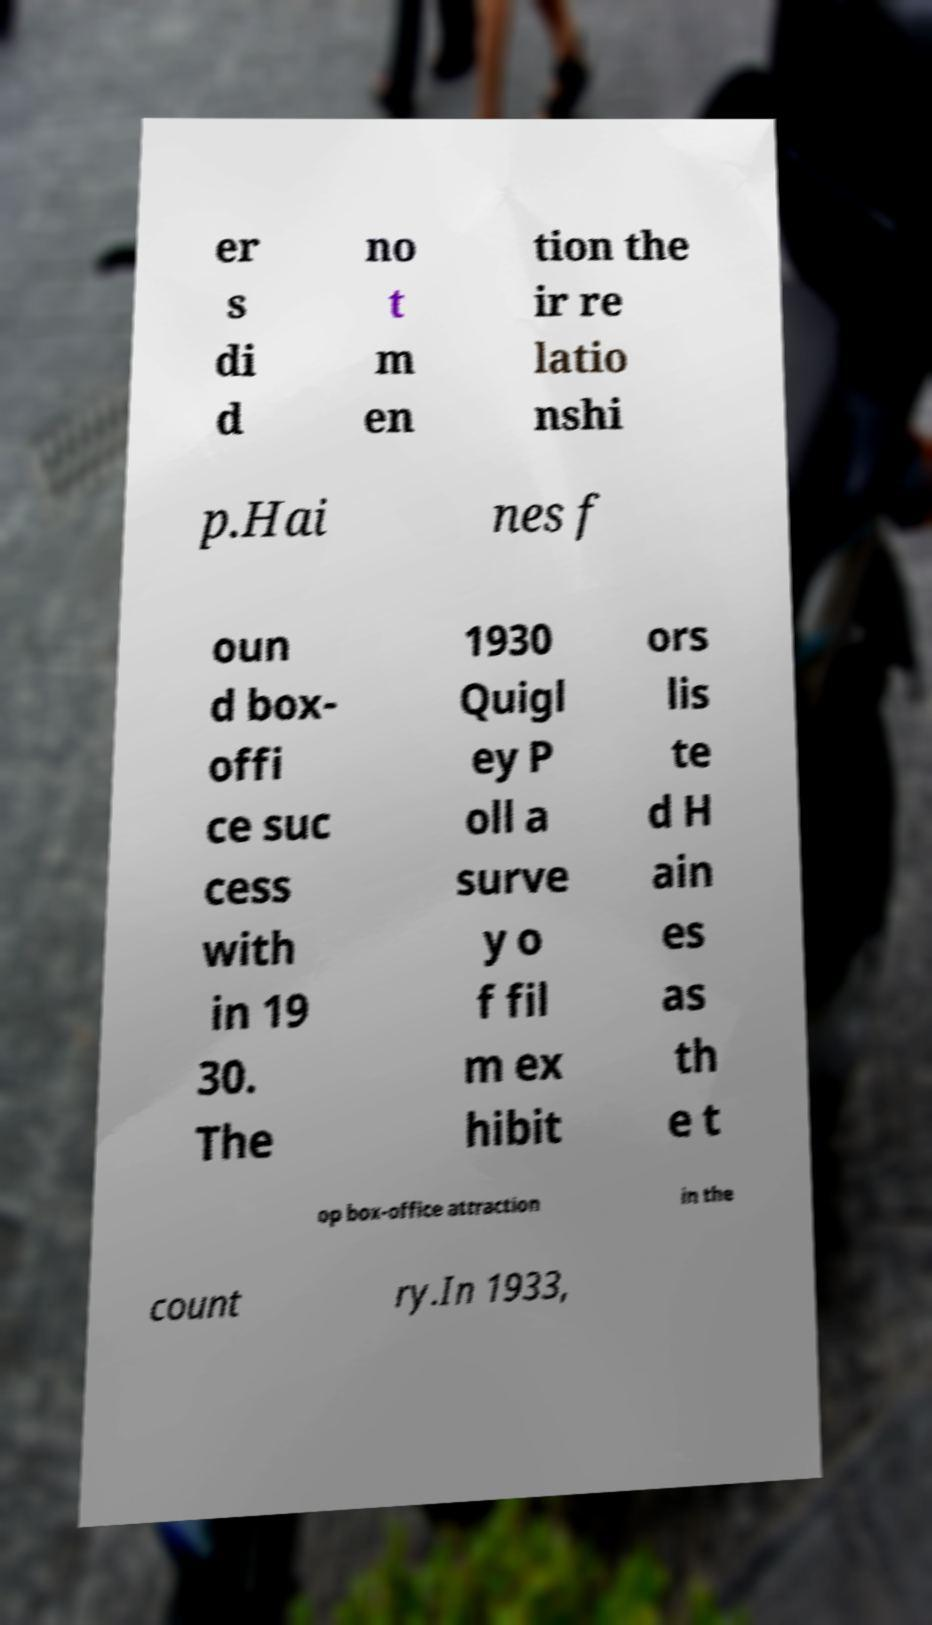What messages or text are displayed in this image? I need them in a readable, typed format. er s di d no t m en tion the ir re latio nshi p.Hai nes f oun d box- offi ce suc cess with in 19 30. The 1930 Quigl ey P oll a surve y o f fil m ex hibit ors lis te d H ain es as th e t op box-office attraction in the count ry.In 1933, 